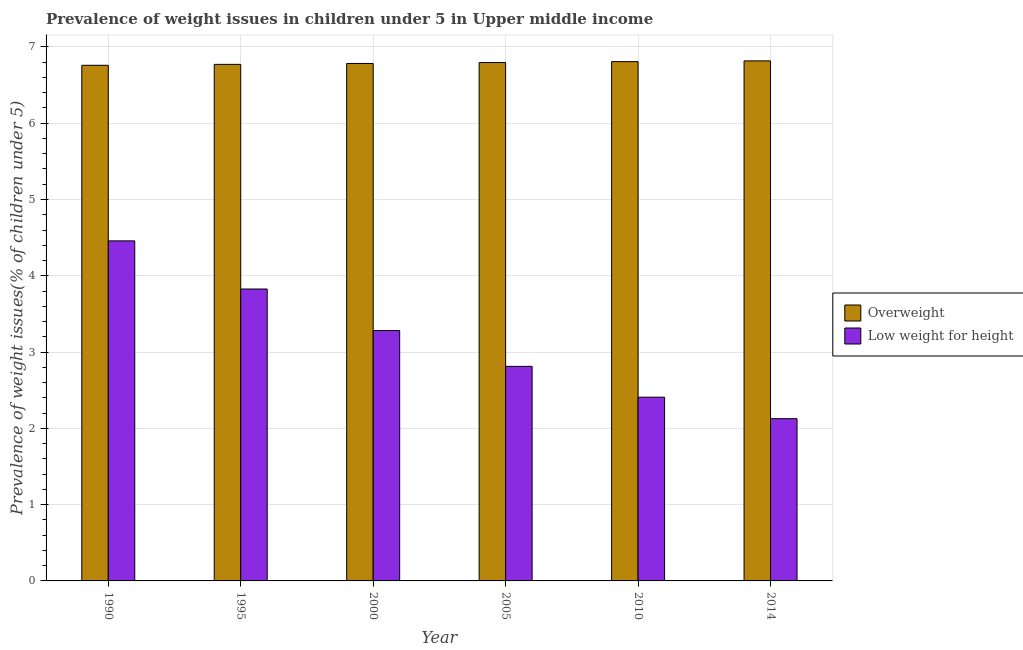How many different coloured bars are there?
Give a very brief answer. 2. How many groups of bars are there?
Give a very brief answer. 6. Are the number of bars per tick equal to the number of legend labels?
Offer a terse response. Yes. How many bars are there on the 5th tick from the left?
Keep it short and to the point. 2. How many bars are there on the 1st tick from the right?
Ensure brevity in your answer.  2. What is the label of the 2nd group of bars from the left?
Offer a very short reply. 1995. In how many cases, is the number of bars for a given year not equal to the number of legend labels?
Give a very brief answer. 0. What is the percentage of overweight children in 2014?
Offer a terse response. 6.82. Across all years, what is the maximum percentage of overweight children?
Offer a very short reply. 6.82. Across all years, what is the minimum percentage of underweight children?
Your answer should be very brief. 2.13. In which year was the percentage of underweight children maximum?
Make the answer very short. 1990. In which year was the percentage of underweight children minimum?
Offer a terse response. 2014. What is the total percentage of overweight children in the graph?
Provide a succinct answer. 40.73. What is the difference between the percentage of underweight children in 2000 and that in 2010?
Your answer should be compact. 0.87. What is the difference between the percentage of underweight children in 1990 and the percentage of overweight children in 2000?
Offer a terse response. 1.18. What is the average percentage of overweight children per year?
Make the answer very short. 6.79. In how many years, is the percentage of overweight children greater than 1.6 %?
Ensure brevity in your answer.  6. What is the ratio of the percentage of underweight children in 1990 to that in 1995?
Offer a terse response. 1.16. Is the percentage of underweight children in 1995 less than that in 2010?
Provide a succinct answer. No. What is the difference between the highest and the second highest percentage of overweight children?
Give a very brief answer. 0.01. What is the difference between the highest and the lowest percentage of underweight children?
Make the answer very short. 2.33. What does the 2nd bar from the left in 1995 represents?
Make the answer very short. Low weight for height. What does the 1st bar from the right in 2000 represents?
Make the answer very short. Low weight for height. How many bars are there?
Give a very brief answer. 12. Are all the bars in the graph horizontal?
Provide a succinct answer. No. How many years are there in the graph?
Provide a short and direct response. 6. What is the difference between two consecutive major ticks on the Y-axis?
Your response must be concise. 1. Does the graph contain grids?
Keep it short and to the point. Yes. Where does the legend appear in the graph?
Make the answer very short. Center right. How are the legend labels stacked?
Offer a terse response. Vertical. What is the title of the graph?
Your answer should be very brief. Prevalence of weight issues in children under 5 in Upper middle income. Does "Investment in Telecom" appear as one of the legend labels in the graph?
Provide a succinct answer. No. What is the label or title of the Y-axis?
Provide a succinct answer. Prevalence of weight issues(% of children under 5). What is the Prevalence of weight issues(% of children under 5) in Overweight in 1990?
Keep it short and to the point. 6.76. What is the Prevalence of weight issues(% of children under 5) in Low weight for height in 1990?
Your response must be concise. 4.46. What is the Prevalence of weight issues(% of children under 5) in Overweight in 1995?
Your answer should be very brief. 6.77. What is the Prevalence of weight issues(% of children under 5) of Low weight for height in 1995?
Your answer should be compact. 3.83. What is the Prevalence of weight issues(% of children under 5) in Overweight in 2000?
Give a very brief answer. 6.78. What is the Prevalence of weight issues(% of children under 5) of Low weight for height in 2000?
Your answer should be compact. 3.28. What is the Prevalence of weight issues(% of children under 5) of Overweight in 2005?
Provide a succinct answer. 6.8. What is the Prevalence of weight issues(% of children under 5) of Low weight for height in 2005?
Ensure brevity in your answer.  2.81. What is the Prevalence of weight issues(% of children under 5) of Overweight in 2010?
Offer a very short reply. 6.81. What is the Prevalence of weight issues(% of children under 5) of Low weight for height in 2010?
Your answer should be very brief. 2.41. What is the Prevalence of weight issues(% of children under 5) in Overweight in 2014?
Make the answer very short. 6.82. What is the Prevalence of weight issues(% of children under 5) in Low weight for height in 2014?
Provide a succinct answer. 2.13. Across all years, what is the maximum Prevalence of weight issues(% of children under 5) of Overweight?
Ensure brevity in your answer.  6.82. Across all years, what is the maximum Prevalence of weight issues(% of children under 5) of Low weight for height?
Ensure brevity in your answer.  4.46. Across all years, what is the minimum Prevalence of weight issues(% of children under 5) of Overweight?
Offer a very short reply. 6.76. Across all years, what is the minimum Prevalence of weight issues(% of children under 5) in Low weight for height?
Keep it short and to the point. 2.13. What is the total Prevalence of weight issues(% of children under 5) of Overweight in the graph?
Keep it short and to the point. 40.73. What is the total Prevalence of weight issues(% of children under 5) in Low weight for height in the graph?
Your answer should be very brief. 18.91. What is the difference between the Prevalence of weight issues(% of children under 5) in Overweight in 1990 and that in 1995?
Offer a terse response. -0.01. What is the difference between the Prevalence of weight issues(% of children under 5) of Low weight for height in 1990 and that in 1995?
Your answer should be compact. 0.63. What is the difference between the Prevalence of weight issues(% of children under 5) of Overweight in 1990 and that in 2000?
Provide a succinct answer. -0.02. What is the difference between the Prevalence of weight issues(% of children under 5) in Low weight for height in 1990 and that in 2000?
Offer a terse response. 1.18. What is the difference between the Prevalence of weight issues(% of children under 5) in Overweight in 1990 and that in 2005?
Make the answer very short. -0.04. What is the difference between the Prevalence of weight issues(% of children under 5) in Low weight for height in 1990 and that in 2005?
Keep it short and to the point. 1.65. What is the difference between the Prevalence of weight issues(% of children under 5) of Overweight in 1990 and that in 2010?
Your response must be concise. -0.05. What is the difference between the Prevalence of weight issues(% of children under 5) of Low weight for height in 1990 and that in 2010?
Offer a terse response. 2.05. What is the difference between the Prevalence of weight issues(% of children under 5) in Overweight in 1990 and that in 2014?
Offer a terse response. -0.06. What is the difference between the Prevalence of weight issues(% of children under 5) in Low weight for height in 1990 and that in 2014?
Ensure brevity in your answer.  2.33. What is the difference between the Prevalence of weight issues(% of children under 5) in Overweight in 1995 and that in 2000?
Give a very brief answer. -0.01. What is the difference between the Prevalence of weight issues(% of children under 5) in Low weight for height in 1995 and that in 2000?
Make the answer very short. 0.54. What is the difference between the Prevalence of weight issues(% of children under 5) of Overweight in 1995 and that in 2005?
Your response must be concise. -0.02. What is the difference between the Prevalence of weight issues(% of children under 5) of Low weight for height in 1995 and that in 2005?
Give a very brief answer. 1.01. What is the difference between the Prevalence of weight issues(% of children under 5) in Overweight in 1995 and that in 2010?
Provide a short and direct response. -0.04. What is the difference between the Prevalence of weight issues(% of children under 5) of Low weight for height in 1995 and that in 2010?
Your answer should be compact. 1.42. What is the difference between the Prevalence of weight issues(% of children under 5) in Overweight in 1995 and that in 2014?
Provide a succinct answer. -0.05. What is the difference between the Prevalence of weight issues(% of children under 5) in Overweight in 2000 and that in 2005?
Offer a very short reply. -0.01. What is the difference between the Prevalence of weight issues(% of children under 5) of Low weight for height in 2000 and that in 2005?
Provide a succinct answer. 0.47. What is the difference between the Prevalence of weight issues(% of children under 5) in Overweight in 2000 and that in 2010?
Provide a succinct answer. -0.02. What is the difference between the Prevalence of weight issues(% of children under 5) in Low weight for height in 2000 and that in 2010?
Your answer should be very brief. 0.87. What is the difference between the Prevalence of weight issues(% of children under 5) of Overweight in 2000 and that in 2014?
Keep it short and to the point. -0.03. What is the difference between the Prevalence of weight issues(% of children under 5) in Low weight for height in 2000 and that in 2014?
Give a very brief answer. 1.16. What is the difference between the Prevalence of weight issues(% of children under 5) of Overweight in 2005 and that in 2010?
Ensure brevity in your answer.  -0.01. What is the difference between the Prevalence of weight issues(% of children under 5) of Low weight for height in 2005 and that in 2010?
Ensure brevity in your answer.  0.4. What is the difference between the Prevalence of weight issues(% of children under 5) in Overweight in 2005 and that in 2014?
Make the answer very short. -0.02. What is the difference between the Prevalence of weight issues(% of children under 5) of Low weight for height in 2005 and that in 2014?
Provide a succinct answer. 0.69. What is the difference between the Prevalence of weight issues(% of children under 5) of Overweight in 2010 and that in 2014?
Provide a short and direct response. -0.01. What is the difference between the Prevalence of weight issues(% of children under 5) in Low weight for height in 2010 and that in 2014?
Offer a very short reply. 0.28. What is the difference between the Prevalence of weight issues(% of children under 5) in Overweight in 1990 and the Prevalence of weight issues(% of children under 5) in Low weight for height in 1995?
Ensure brevity in your answer.  2.93. What is the difference between the Prevalence of weight issues(% of children under 5) of Overweight in 1990 and the Prevalence of weight issues(% of children under 5) of Low weight for height in 2000?
Your answer should be compact. 3.48. What is the difference between the Prevalence of weight issues(% of children under 5) in Overweight in 1990 and the Prevalence of weight issues(% of children under 5) in Low weight for height in 2005?
Provide a short and direct response. 3.95. What is the difference between the Prevalence of weight issues(% of children under 5) in Overweight in 1990 and the Prevalence of weight issues(% of children under 5) in Low weight for height in 2010?
Offer a terse response. 4.35. What is the difference between the Prevalence of weight issues(% of children under 5) in Overweight in 1990 and the Prevalence of weight issues(% of children under 5) in Low weight for height in 2014?
Ensure brevity in your answer.  4.63. What is the difference between the Prevalence of weight issues(% of children under 5) in Overweight in 1995 and the Prevalence of weight issues(% of children under 5) in Low weight for height in 2000?
Provide a short and direct response. 3.49. What is the difference between the Prevalence of weight issues(% of children under 5) in Overweight in 1995 and the Prevalence of weight issues(% of children under 5) in Low weight for height in 2005?
Keep it short and to the point. 3.96. What is the difference between the Prevalence of weight issues(% of children under 5) of Overweight in 1995 and the Prevalence of weight issues(% of children under 5) of Low weight for height in 2010?
Your answer should be compact. 4.36. What is the difference between the Prevalence of weight issues(% of children under 5) of Overweight in 1995 and the Prevalence of weight issues(% of children under 5) of Low weight for height in 2014?
Provide a short and direct response. 4.64. What is the difference between the Prevalence of weight issues(% of children under 5) of Overweight in 2000 and the Prevalence of weight issues(% of children under 5) of Low weight for height in 2005?
Give a very brief answer. 3.97. What is the difference between the Prevalence of weight issues(% of children under 5) in Overweight in 2000 and the Prevalence of weight issues(% of children under 5) in Low weight for height in 2010?
Your answer should be compact. 4.37. What is the difference between the Prevalence of weight issues(% of children under 5) of Overweight in 2000 and the Prevalence of weight issues(% of children under 5) of Low weight for height in 2014?
Make the answer very short. 4.66. What is the difference between the Prevalence of weight issues(% of children under 5) in Overweight in 2005 and the Prevalence of weight issues(% of children under 5) in Low weight for height in 2010?
Give a very brief answer. 4.39. What is the difference between the Prevalence of weight issues(% of children under 5) in Overweight in 2005 and the Prevalence of weight issues(% of children under 5) in Low weight for height in 2014?
Your response must be concise. 4.67. What is the difference between the Prevalence of weight issues(% of children under 5) of Overweight in 2010 and the Prevalence of weight issues(% of children under 5) of Low weight for height in 2014?
Your response must be concise. 4.68. What is the average Prevalence of weight issues(% of children under 5) of Overweight per year?
Make the answer very short. 6.79. What is the average Prevalence of weight issues(% of children under 5) of Low weight for height per year?
Offer a very short reply. 3.15. In the year 1990, what is the difference between the Prevalence of weight issues(% of children under 5) in Overweight and Prevalence of weight issues(% of children under 5) in Low weight for height?
Offer a terse response. 2.3. In the year 1995, what is the difference between the Prevalence of weight issues(% of children under 5) of Overweight and Prevalence of weight issues(% of children under 5) of Low weight for height?
Provide a short and direct response. 2.94. In the year 2000, what is the difference between the Prevalence of weight issues(% of children under 5) in Overweight and Prevalence of weight issues(% of children under 5) in Low weight for height?
Provide a short and direct response. 3.5. In the year 2005, what is the difference between the Prevalence of weight issues(% of children under 5) of Overweight and Prevalence of weight issues(% of children under 5) of Low weight for height?
Your answer should be compact. 3.98. In the year 2010, what is the difference between the Prevalence of weight issues(% of children under 5) in Overweight and Prevalence of weight issues(% of children under 5) in Low weight for height?
Provide a succinct answer. 4.4. In the year 2014, what is the difference between the Prevalence of weight issues(% of children under 5) of Overweight and Prevalence of weight issues(% of children under 5) of Low weight for height?
Make the answer very short. 4.69. What is the ratio of the Prevalence of weight issues(% of children under 5) in Low weight for height in 1990 to that in 1995?
Provide a succinct answer. 1.16. What is the ratio of the Prevalence of weight issues(% of children under 5) of Overweight in 1990 to that in 2000?
Ensure brevity in your answer.  1. What is the ratio of the Prevalence of weight issues(% of children under 5) in Low weight for height in 1990 to that in 2000?
Provide a short and direct response. 1.36. What is the ratio of the Prevalence of weight issues(% of children under 5) in Overweight in 1990 to that in 2005?
Give a very brief answer. 0.99. What is the ratio of the Prevalence of weight issues(% of children under 5) of Low weight for height in 1990 to that in 2005?
Provide a succinct answer. 1.58. What is the ratio of the Prevalence of weight issues(% of children under 5) of Overweight in 1990 to that in 2010?
Offer a terse response. 0.99. What is the ratio of the Prevalence of weight issues(% of children under 5) in Low weight for height in 1990 to that in 2010?
Provide a succinct answer. 1.85. What is the ratio of the Prevalence of weight issues(% of children under 5) in Overweight in 1990 to that in 2014?
Offer a terse response. 0.99. What is the ratio of the Prevalence of weight issues(% of children under 5) of Low weight for height in 1990 to that in 2014?
Make the answer very short. 2.1. What is the ratio of the Prevalence of weight issues(% of children under 5) of Low weight for height in 1995 to that in 2000?
Provide a short and direct response. 1.17. What is the ratio of the Prevalence of weight issues(% of children under 5) of Low weight for height in 1995 to that in 2005?
Offer a very short reply. 1.36. What is the ratio of the Prevalence of weight issues(% of children under 5) in Low weight for height in 1995 to that in 2010?
Your response must be concise. 1.59. What is the ratio of the Prevalence of weight issues(% of children under 5) of Low weight for height in 1995 to that in 2014?
Give a very brief answer. 1.8. What is the ratio of the Prevalence of weight issues(% of children under 5) of Low weight for height in 2000 to that in 2005?
Offer a terse response. 1.17. What is the ratio of the Prevalence of weight issues(% of children under 5) in Low weight for height in 2000 to that in 2010?
Your answer should be compact. 1.36. What is the ratio of the Prevalence of weight issues(% of children under 5) of Low weight for height in 2000 to that in 2014?
Your answer should be very brief. 1.54. What is the ratio of the Prevalence of weight issues(% of children under 5) of Overweight in 2005 to that in 2010?
Keep it short and to the point. 1. What is the ratio of the Prevalence of weight issues(% of children under 5) in Low weight for height in 2005 to that in 2010?
Ensure brevity in your answer.  1.17. What is the ratio of the Prevalence of weight issues(% of children under 5) of Overweight in 2005 to that in 2014?
Provide a short and direct response. 1. What is the ratio of the Prevalence of weight issues(% of children under 5) in Low weight for height in 2005 to that in 2014?
Give a very brief answer. 1.32. What is the ratio of the Prevalence of weight issues(% of children under 5) in Overweight in 2010 to that in 2014?
Provide a succinct answer. 1. What is the ratio of the Prevalence of weight issues(% of children under 5) in Low weight for height in 2010 to that in 2014?
Give a very brief answer. 1.13. What is the difference between the highest and the second highest Prevalence of weight issues(% of children under 5) in Overweight?
Your answer should be very brief. 0.01. What is the difference between the highest and the second highest Prevalence of weight issues(% of children under 5) in Low weight for height?
Make the answer very short. 0.63. What is the difference between the highest and the lowest Prevalence of weight issues(% of children under 5) of Overweight?
Make the answer very short. 0.06. What is the difference between the highest and the lowest Prevalence of weight issues(% of children under 5) in Low weight for height?
Keep it short and to the point. 2.33. 